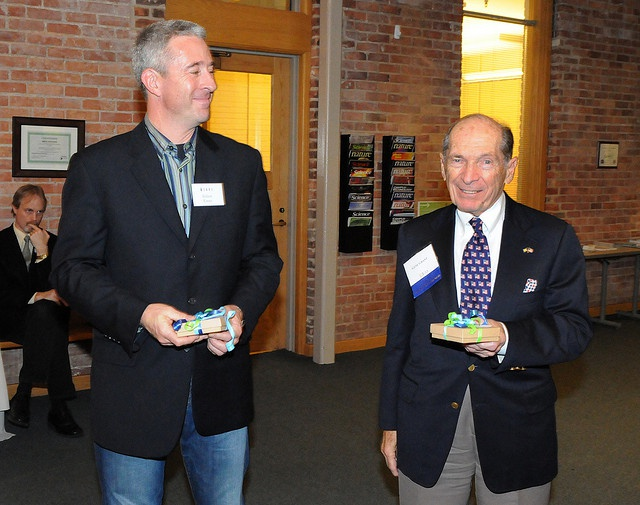Describe the objects in this image and their specific colors. I can see people in brown, black, lightpink, gray, and navy tones, people in brown, black, gray, white, and salmon tones, people in brown, black, and maroon tones, tie in brown, navy, blue, purple, and darkgray tones, and tie in brown, gray, and black tones in this image. 